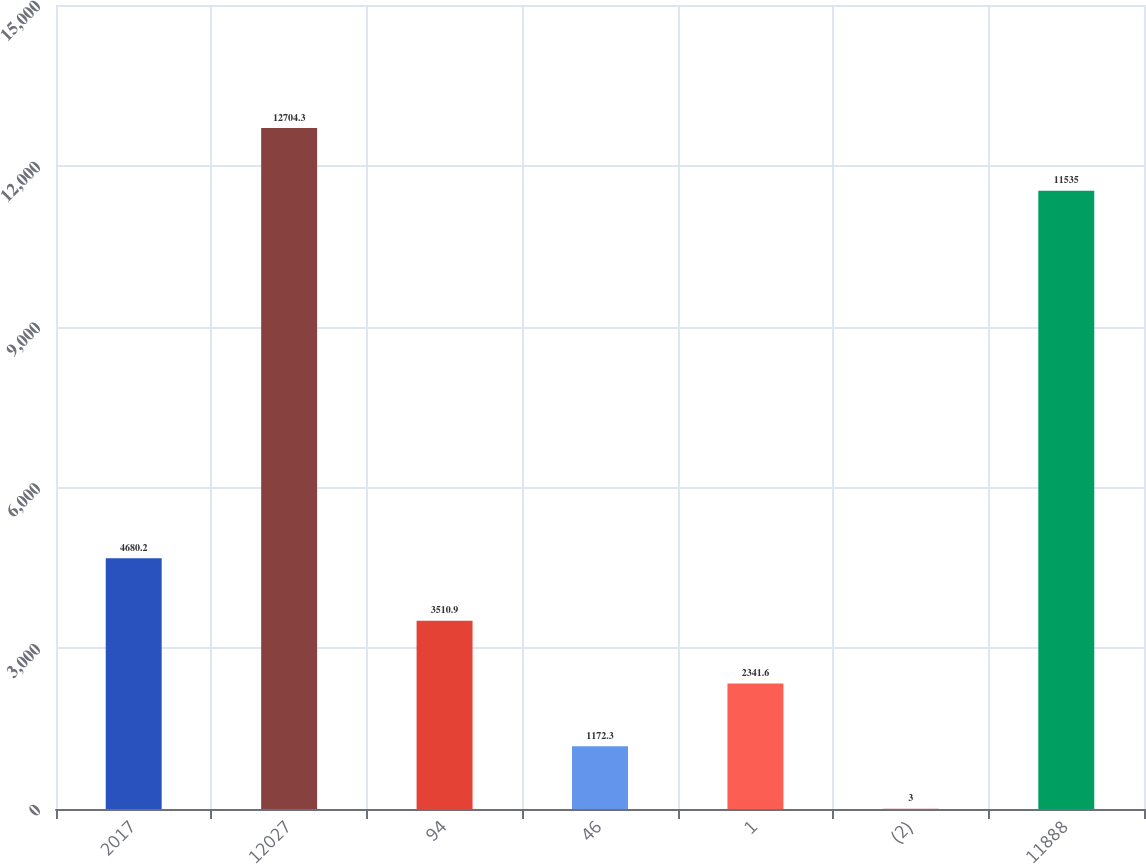Convert chart to OTSL. <chart><loc_0><loc_0><loc_500><loc_500><bar_chart><fcel>2017<fcel>12027<fcel>94<fcel>46<fcel>1<fcel>(2)<fcel>11888<nl><fcel>4680.2<fcel>12704.3<fcel>3510.9<fcel>1172.3<fcel>2341.6<fcel>3<fcel>11535<nl></chart> 